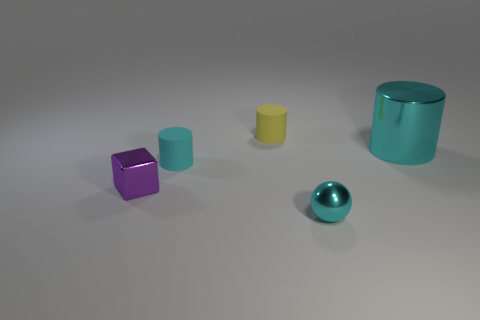Is the big cylinder the same color as the metallic ball?
Offer a very short reply. Yes. What number of objects are cubes or small things in front of the yellow object?
Keep it short and to the point. 3. Are there the same number of small objects to the left of the cyan rubber cylinder and yellow things?
Make the answer very short. Yes. What shape is the large cyan thing that is the same material as the small block?
Give a very brief answer. Cylinder. Are there any tiny rubber things that have the same color as the large metallic cylinder?
Keep it short and to the point. Yes. How many shiny things are either tiny purple cubes or cylinders?
Ensure brevity in your answer.  2. There is a small cyan object left of the tiny metal ball; how many yellow cylinders are on the left side of it?
Your answer should be compact. 0. What number of tiny things are made of the same material as the large cyan object?
Provide a short and direct response. 2. How many tiny things are either brown rubber cylinders or purple things?
Offer a terse response. 1. There is a small thing that is on the right side of the purple cube and left of the yellow thing; what shape is it?
Keep it short and to the point. Cylinder. 